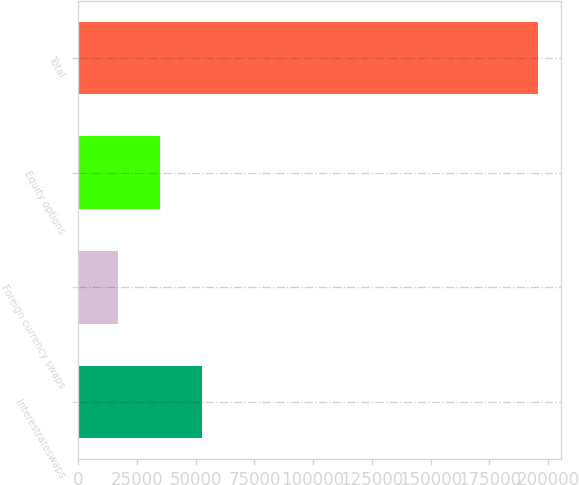<chart> <loc_0><loc_0><loc_500><loc_500><bar_chart><fcel>Interestrateswaps<fcel>Foreign currency swaps<fcel>Equity options<fcel>Total<nl><fcel>52678.6<fcel>16879<fcel>34778.8<fcel>195877<nl></chart> 